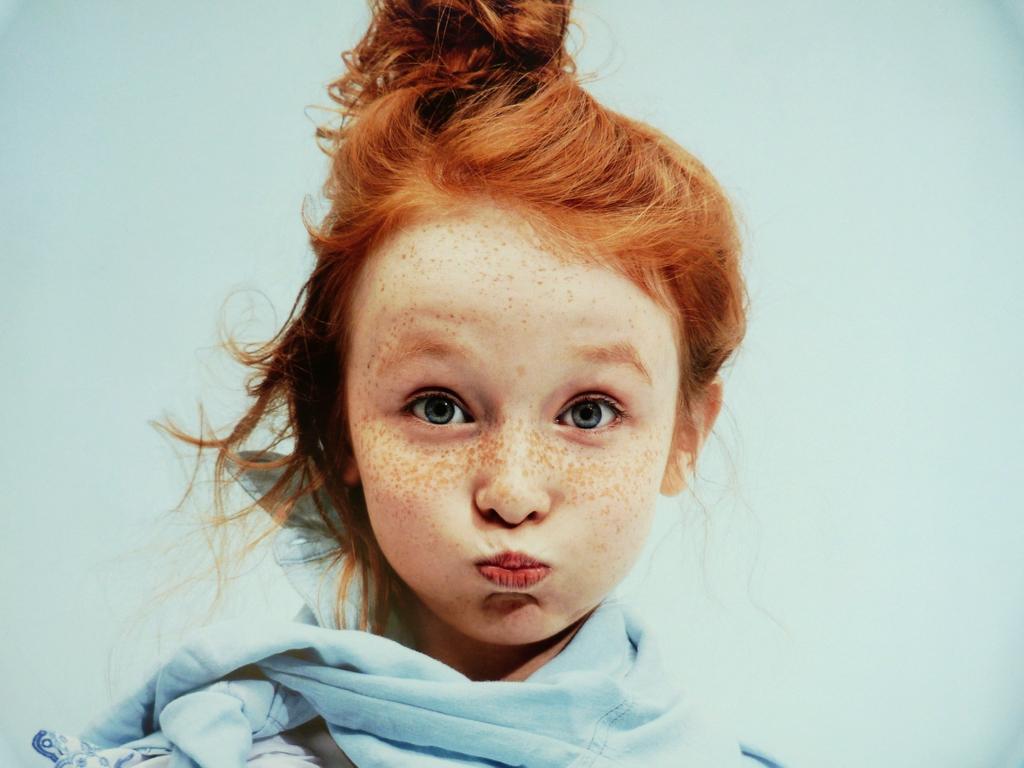Please provide a concise description of this image. In the image there is a girl in golden hair and blue scarf standing in front of wall. 